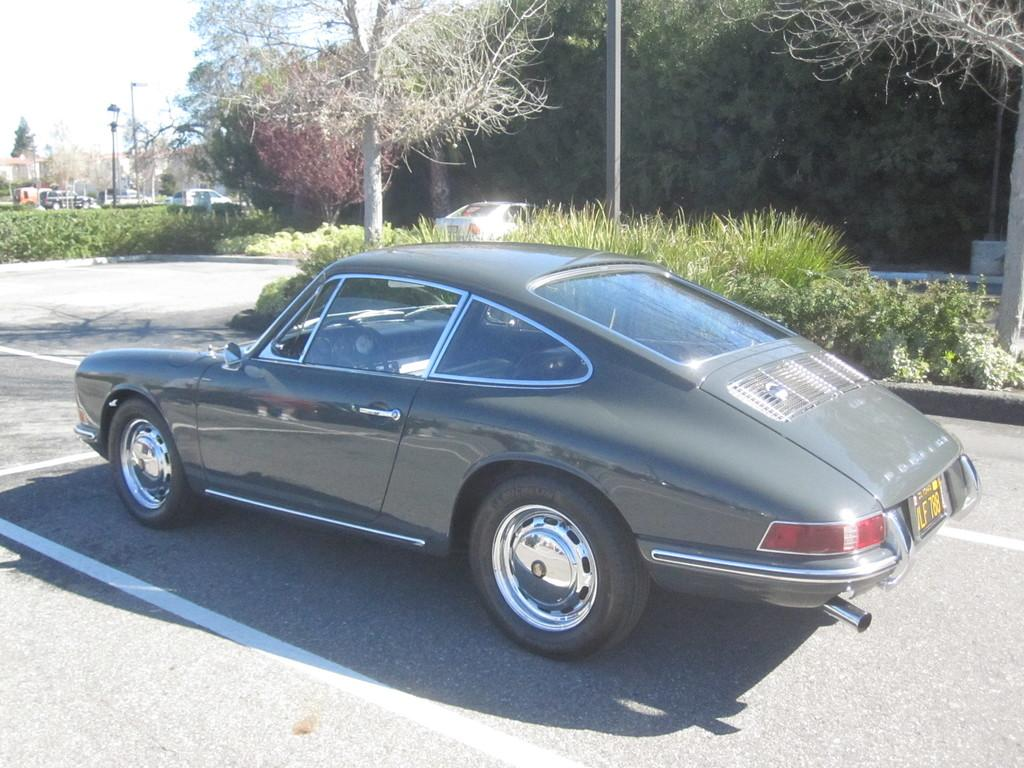What is the main subject in the center of the image? There is a car in the center of the image. What can be seen in the background of the image? There are trees and other cars in the background of the image. Are there any balls or swings visible in the image? No, there are no balls or swings present in the image. Can you see any flowers in the image? No, there are no flowers visible in the image. 